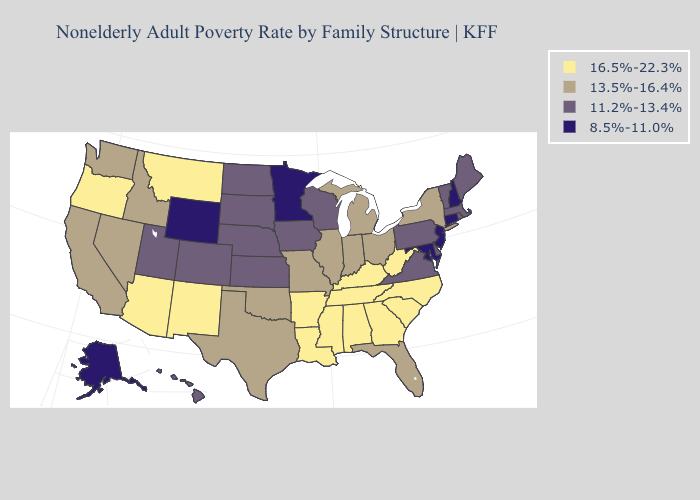What is the value of Pennsylvania?
Quick response, please. 11.2%-13.4%. What is the value of Tennessee?
Keep it brief. 16.5%-22.3%. Does Florida have a lower value than Indiana?
Answer briefly. No. Is the legend a continuous bar?
Be succinct. No. Is the legend a continuous bar?
Be succinct. No. What is the highest value in states that border Louisiana?
Be succinct. 16.5%-22.3%. What is the value of South Dakota?
Write a very short answer. 11.2%-13.4%. Which states hav the highest value in the MidWest?
Short answer required. Illinois, Indiana, Michigan, Missouri, Ohio. What is the highest value in the USA?
Answer briefly. 16.5%-22.3%. Which states have the highest value in the USA?
Be succinct. Alabama, Arizona, Arkansas, Georgia, Kentucky, Louisiana, Mississippi, Montana, New Mexico, North Carolina, Oregon, South Carolina, Tennessee, West Virginia. Does New Mexico have a higher value than Georgia?
Quick response, please. No. What is the lowest value in states that border Virginia?
Short answer required. 8.5%-11.0%. Does the map have missing data?
Answer briefly. No. Name the states that have a value in the range 11.2%-13.4%?
Concise answer only. Colorado, Delaware, Hawaii, Iowa, Kansas, Maine, Massachusetts, Nebraska, North Dakota, Pennsylvania, Rhode Island, South Dakota, Utah, Vermont, Virginia, Wisconsin. Name the states that have a value in the range 11.2%-13.4%?
Give a very brief answer. Colorado, Delaware, Hawaii, Iowa, Kansas, Maine, Massachusetts, Nebraska, North Dakota, Pennsylvania, Rhode Island, South Dakota, Utah, Vermont, Virginia, Wisconsin. 